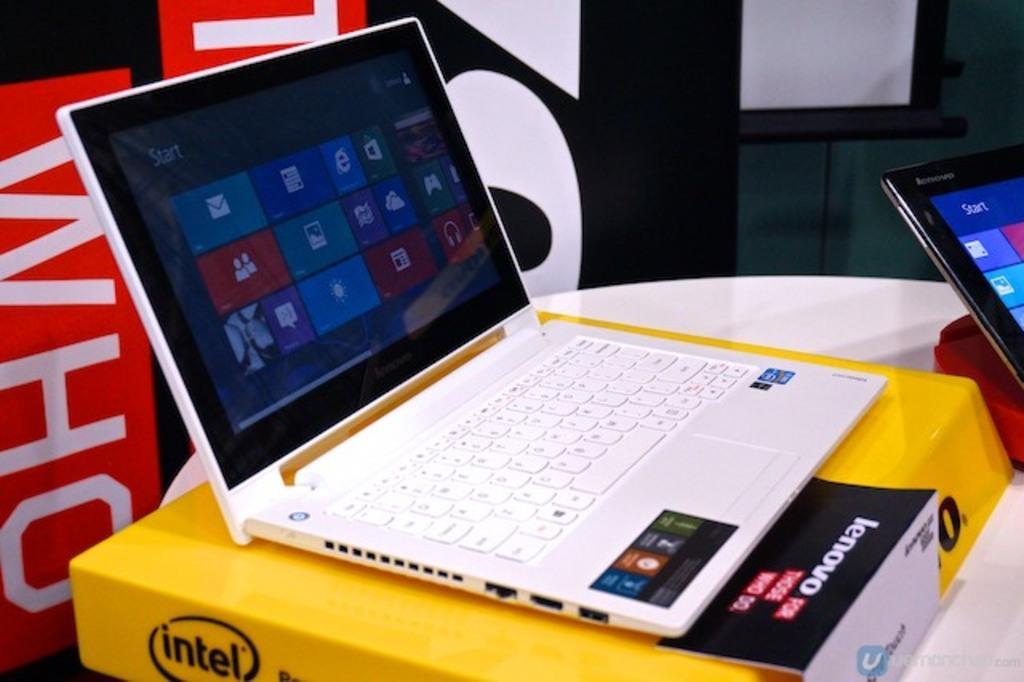Could you give a brief overview of what you see in this image? In this image there is a laptop on the laptop box. The box is on the table. On the right side there is another laptop. In the background there is a banner and a screen. 